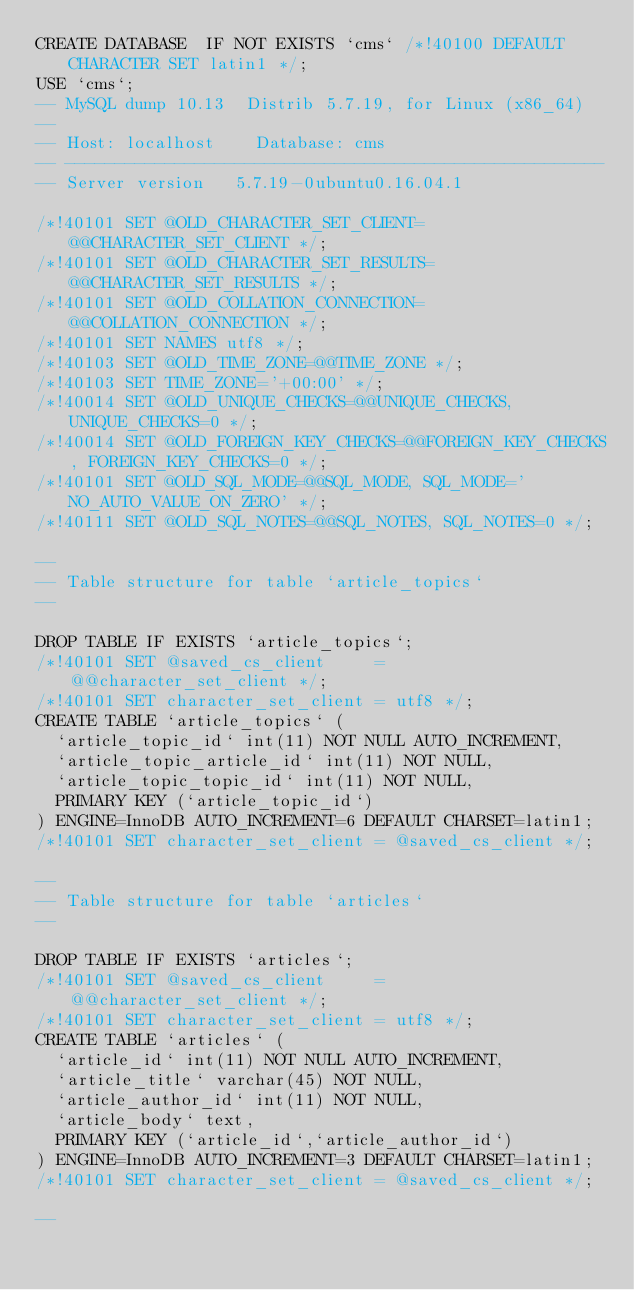<code> <loc_0><loc_0><loc_500><loc_500><_SQL_>CREATE DATABASE  IF NOT EXISTS `cms` /*!40100 DEFAULT CHARACTER SET latin1 */;
USE `cms`;
-- MySQL dump 10.13  Distrib 5.7.19, for Linux (x86_64)
--
-- Host: localhost    Database: cms
-- ------------------------------------------------------
-- Server version	5.7.19-0ubuntu0.16.04.1

/*!40101 SET @OLD_CHARACTER_SET_CLIENT=@@CHARACTER_SET_CLIENT */;
/*!40101 SET @OLD_CHARACTER_SET_RESULTS=@@CHARACTER_SET_RESULTS */;
/*!40101 SET @OLD_COLLATION_CONNECTION=@@COLLATION_CONNECTION */;
/*!40101 SET NAMES utf8 */;
/*!40103 SET @OLD_TIME_ZONE=@@TIME_ZONE */;
/*!40103 SET TIME_ZONE='+00:00' */;
/*!40014 SET @OLD_UNIQUE_CHECKS=@@UNIQUE_CHECKS, UNIQUE_CHECKS=0 */;
/*!40014 SET @OLD_FOREIGN_KEY_CHECKS=@@FOREIGN_KEY_CHECKS, FOREIGN_KEY_CHECKS=0 */;
/*!40101 SET @OLD_SQL_MODE=@@SQL_MODE, SQL_MODE='NO_AUTO_VALUE_ON_ZERO' */;
/*!40111 SET @OLD_SQL_NOTES=@@SQL_NOTES, SQL_NOTES=0 */;

--
-- Table structure for table `article_topics`
--

DROP TABLE IF EXISTS `article_topics`;
/*!40101 SET @saved_cs_client     = @@character_set_client */;
/*!40101 SET character_set_client = utf8 */;
CREATE TABLE `article_topics` (
  `article_topic_id` int(11) NOT NULL AUTO_INCREMENT,
  `article_topic_article_id` int(11) NOT NULL,
  `article_topic_topic_id` int(11) NOT NULL,
  PRIMARY KEY (`article_topic_id`)
) ENGINE=InnoDB AUTO_INCREMENT=6 DEFAULT CHARSET=latin1;
/*!40101 SET character_set_client = @saved_cs_client */;

--
-- Table structure for table `articles`
--

DROP TABLE IF EXISTS `articles`;
/*!40101 SET @saved_cs_client     = @@character_set_client */;
/*!40101 SET character_set_client = utf8 */;
CREATE TABLE `articles` (
  `article_id` int(11) NOT NULL AUTO_INCREMENT,
  `article_title` varchar(45) NOT NULL,
  `article_author_id` int(11) NOT NULL,
  `article_body` text,
  PRIMARY KEY (`article_id`,`article_author_id`)
) ENGINE=InnoDB AUTO_INCREMENT=3 DEFAULT CHARSET=latin1;
/*!40101 SET character_set_client = @saved_cs_client */;

--</code> 